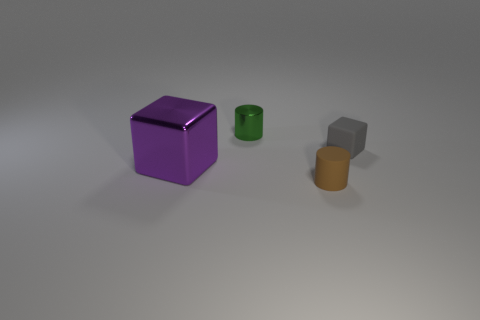Subtract all gray blocks. How many blocks are left? 1 Add 4 small red matte blocks. How many objects exist? 8 Subtract 1 cubes. How many cubes are left? 1 Subtract all brown cubes. Subtract all red spheres. How many cubes are left? 2 Subtract all tiny blocks. Subtract all purple objects. How many objects are left? 2 Add 3 big purple objects. How many big purple objects are left? 4 Add 1 tiny cylinders. How many tiny cylinders exist? 3 Subtract 1 purple blocks. How many objects are left? 3 